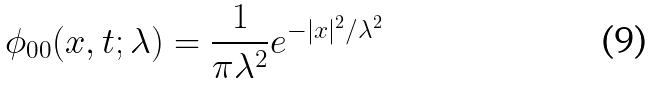Convert formula to latex. <formula><loc_0><loc_0><loc_500><loc_500>\phi _ { 0 0 } ( x , t ; \lambda ) = \frac { 1 } { \pi \lambda ^ { 2 } } e ^ { - | x | ^ { 2 } / \lambda ^ { 2 } }</formula> 